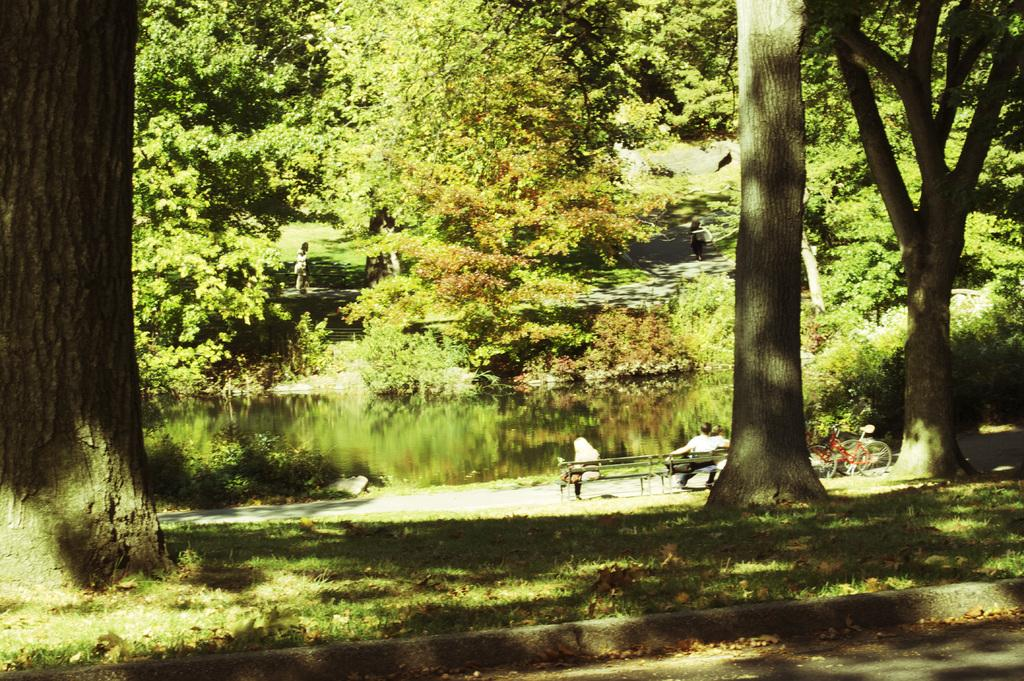What type of vegetation is present on the ground in the front of the image? There is grass on the ground in the front of the image. What can be seen in the background of the image? There are trees, water, bicycles, and persons sitting on a bench in the background of the image. What discovery was made in the box in the image? There is no box present in the image, so no discovery can be made. 